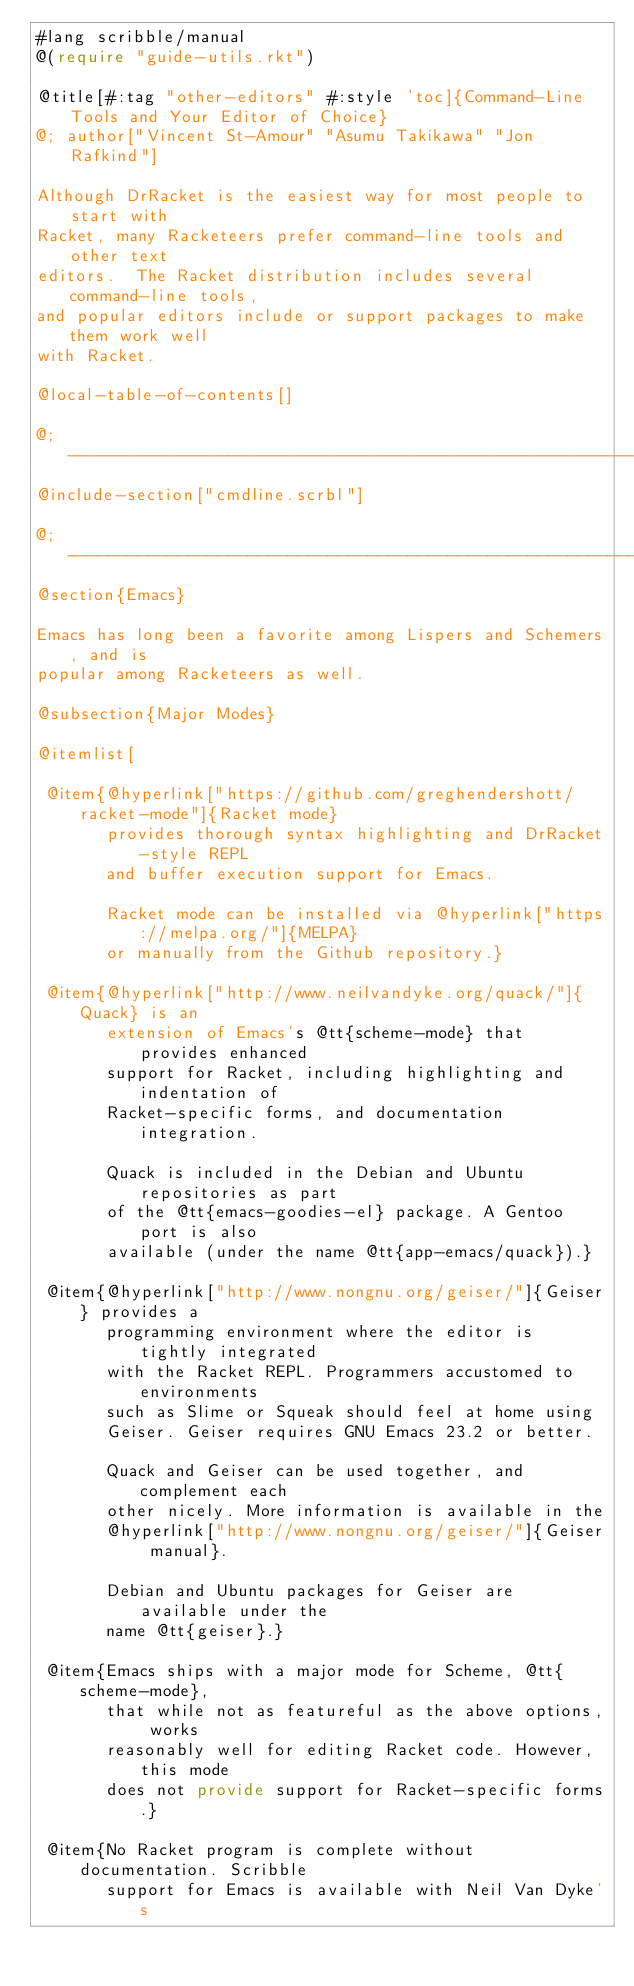<code> <loc_0><loc_0><loc_500><loc_500><_Racket_>#lang scribble/manual
@(require "guide-utils.rkt")

@title[#:tag "other-editors" #:style 'toc]{Command-Line Tools and Your Editor of Choice}
@; author["Vincent St-Amour" "Asumu Takikawa" "Jon Rafkind"]

Although DrRacket is the easiest way for most people to start with
Racket, many Racketeers prefer command-line tools and other text
editors.  The Racket distribution includes several command-line tools,
and popular editors include or support packages to make them work well
with Racket.

@local-table-of-contents[]

@; ------------------------------------------------------------
@include-section["cmdline.scrbl"]

@; ------------------------------------------------------------
@section{Emacs}

Emacs has long been a favorite among Lispers and Schemers, and is
popular among Racketeers as well.

@subsection{Major Modes}

@itemlist[

 @item{@hyperlink["https://github.com/greghendershott/racket-mode"]{Racket mode}
       provides thorough syntax highlighting and DrRacket-style REPL
       and buffer execution support for Emacs.

       Racket mode can be installed via @hyperlink["https://melpa.org/"]{MELPA}
       or manually from the Github repository.}

 @item{@hyperlink["http://www.neilvandyke.org/quack/"]{Quack} is an
       extension of Emacs's @tt{scheme-mode} that provides enhanced
       support for Racket, including highlighting and indentation of
       Racket-specific forms, and documentation integration.

       Quack is included in the Debian and Ubuntu repositories as part
       of the @tt{emacs-goodies-el} package. A Gentoo port is also
       available (under the name @tt{app-emacs/quack}).}

 @item{@hyperlink["http://www.nongnu.org/geiser/"]{Geiser} provides a
       programming environment where the editor is tightly integrated
       with the Racket REPL. Programmers accustomed to environments
       such as Slime or Squeak should feel at home using
       Geiser. Geiser requires GNU Emacs 23.2 or better.

       Quack and Geiser can be used together, and complement each
       other nicely. More information is available in the
       @hyperlink["http://www.nongnu.org/geiser/"]{Geiser manual}.

       Debian and Ubuntu packages for Geiser are available under the
       name @tt{geiser}.}

 @item{Emacs ships with a major mode for Scheme, @tt{scheme-mode},
       that while not as featureful as the above options, works
       reasonably well for editing Racket code. However, this mode
       does not provide support for Racket-specific forms.}

 @item{No Racket program is complete without documentation. Scribble
       support for Emacs is available with Neil Van Dyke's</code> 